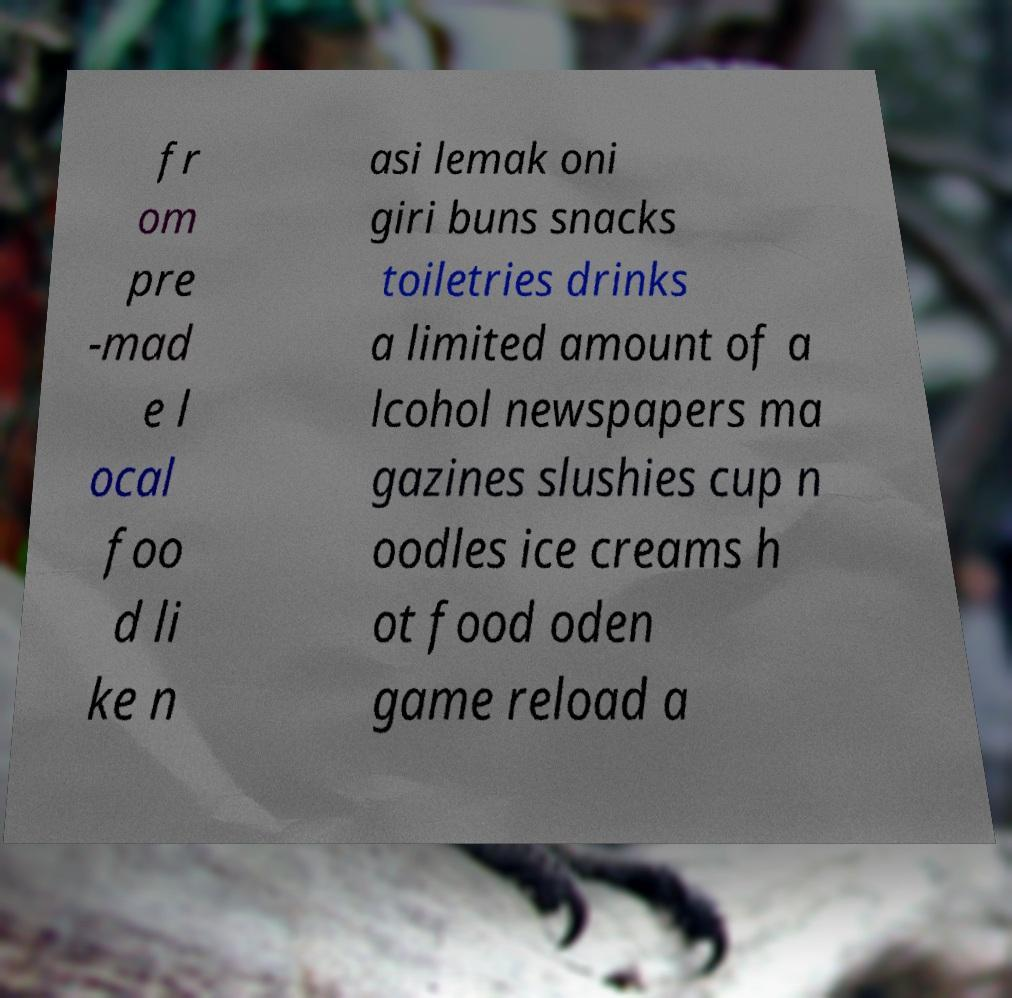Can you accurately transcribe the text from the provided image for me? fr om pre -mad e l ocal foo d li ke n asi lemak oni giri buns snacks toiletries drinks a limited amount of a lcohol newspapers ma gazines slushies cup n oodles ice creams h ot food oden game reload a 